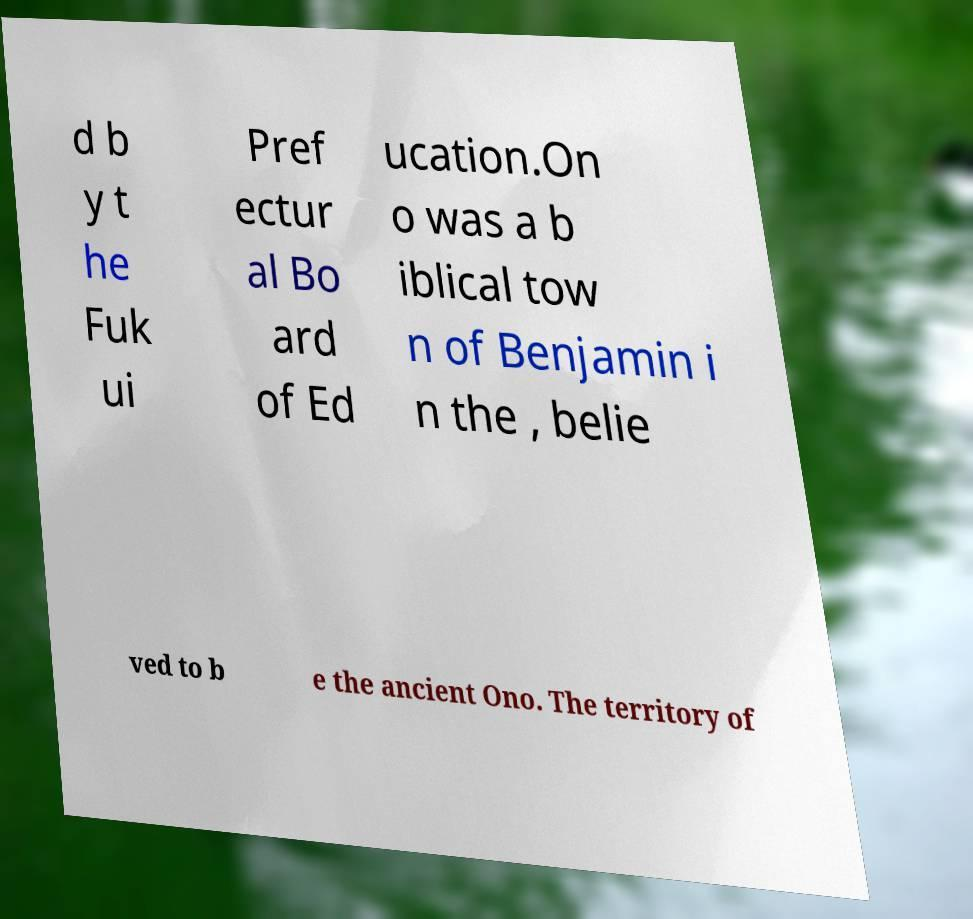Can you accurately transcribe the text from the provided image for me? d b y t he Fuk ui Pref ectur al Bo ard of Ed ucation.On o was a b iblical tow n of Benjamin i n the , belie ved to b e the ancient Ono. The territory of 